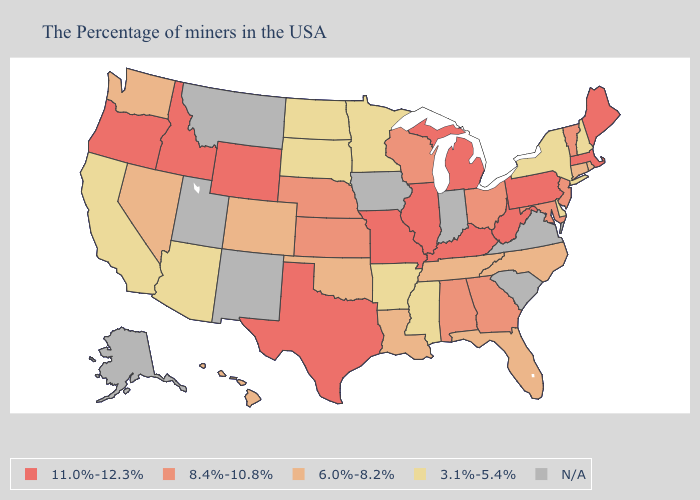Does New Jersey have the lowest value in the Northeast?
Write a very short answer. No. What is the highest value in the South ?
Concise answer only. 11.0%-12.3%. What is the value of West Virginia?
Answer briefly. 11.0%-12.3%. Does Arkansas have the lowest value in the South?
Quick response, please. Yes. Name the states that have a value in the range 11.0%-12.3%?
Answer briefly. Maine, Massachusetts, Pennsylvania, West Virginia, Michigan, Kentucky, Illinois, Missouri, Texas, Wyoming, Idaho, Oregon. Among the states that border Massachusetts , does Connecticut have the highest value?
Concise answer only. No. Name the states that have a value in the range 3.1%-5.4%?
Give a very brief answer. New Hampshire, New York, Delaware, Mississippi, Arkansas, Minnesota, South Dakota, North Dakota, Arizona, California. Among the states that border Louisiana , does Texas have the highest value?
Be succinct. Yes. Among the states that border California , which have the highest value?
Quick response, please. Oregon. What is the lowest value in the South?
Short answer required. 3.1%-5.4%. Among the states that border Indiana , which have the lowest value?
Answer briefly. Ohio. What is the value of Ohio?
Short answer required. 8.4%-10.8%. Which states have the lowest value in the USA?
Quick response, please. New Hampshire, New York, Delaware, Mississippi, Arkansas, Minnesota, South Dakota, North Dakota, Arizona, California. 